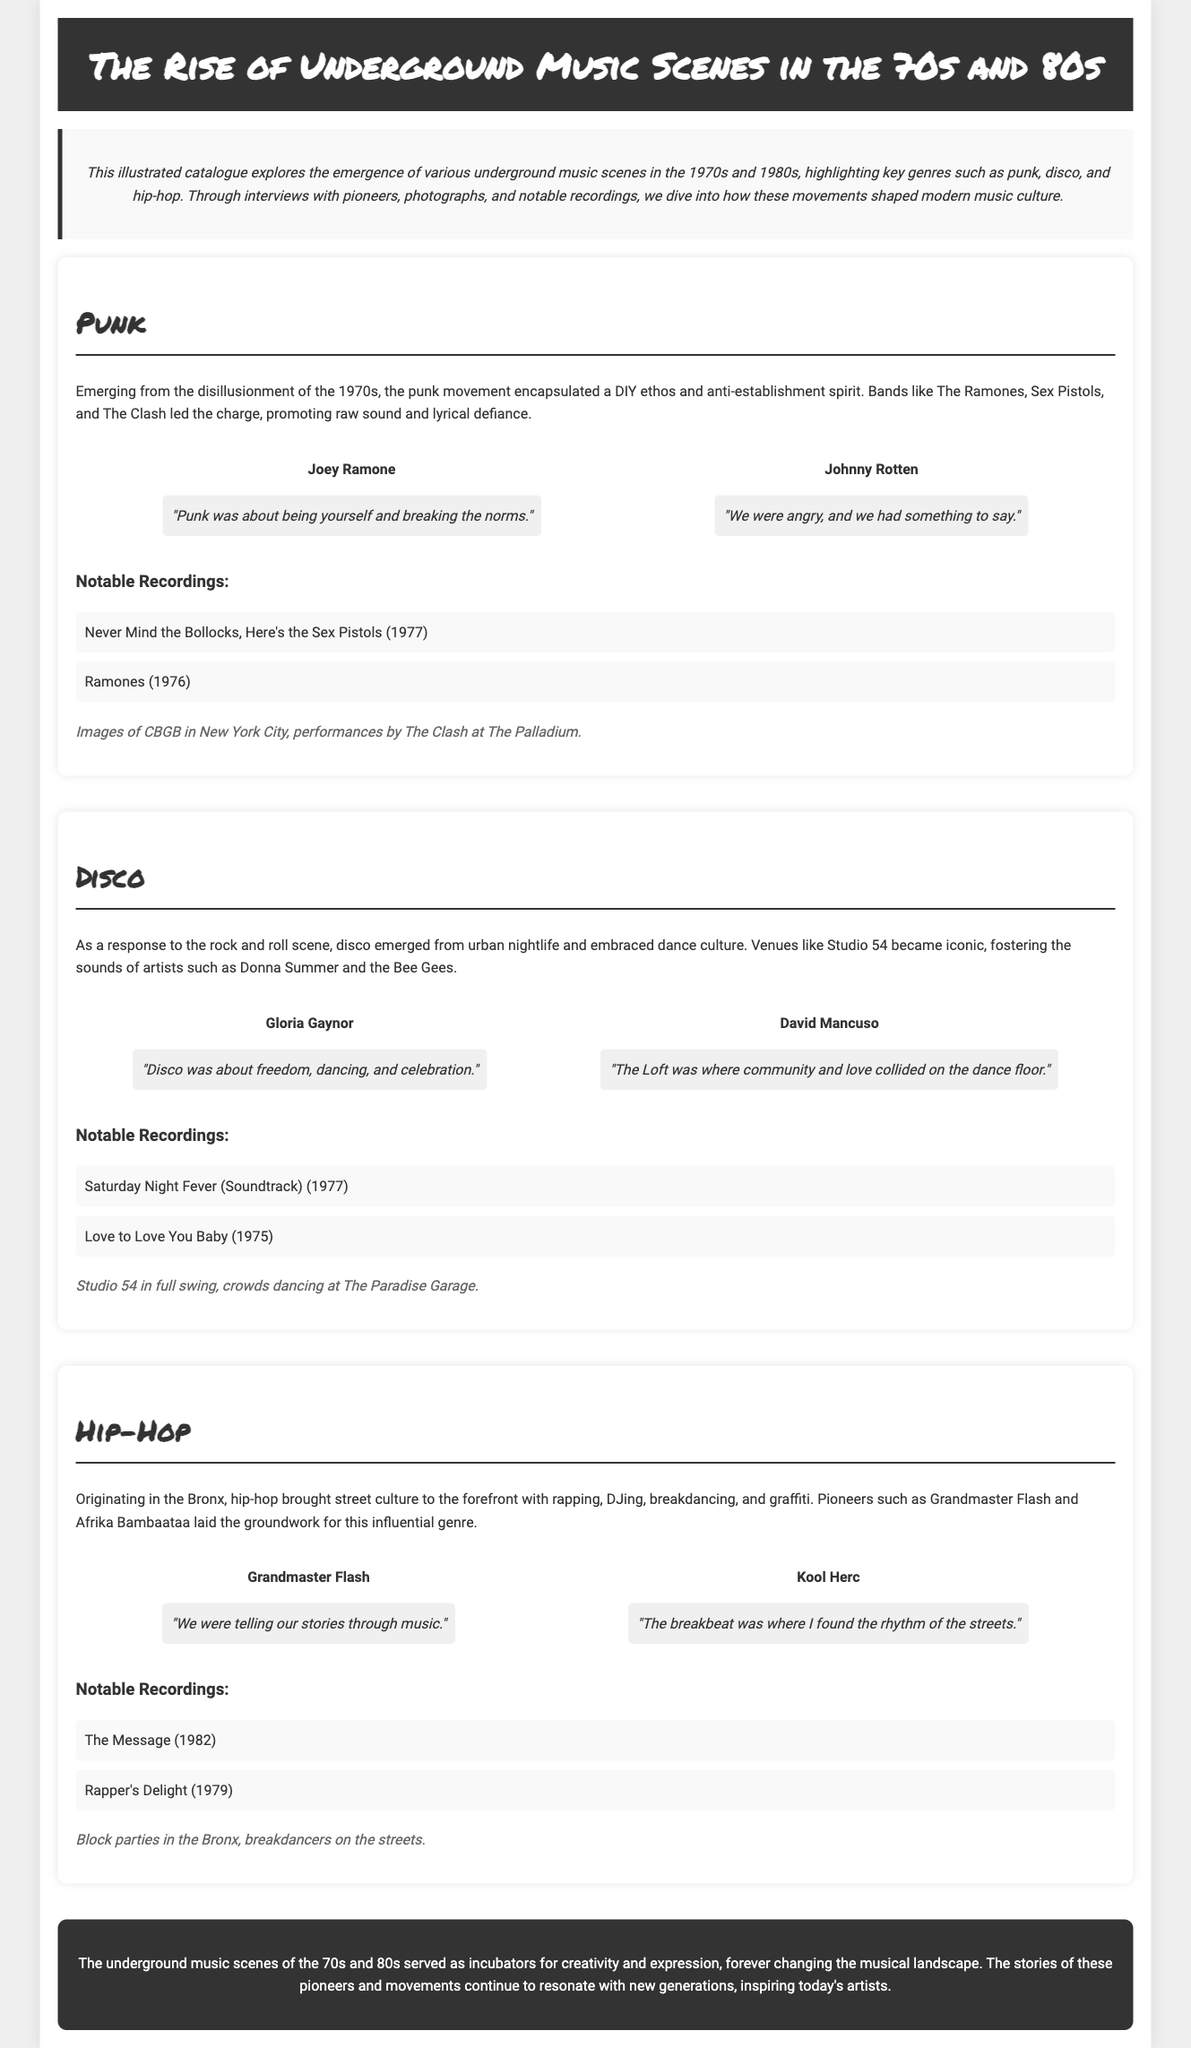what is the title of the catalogue? The title of the catalogue is prominently displayed in the header section, which reads "The Rise of Underground Music Scenes in the 70s and 80s."
Answer: The Rise of Underground Music Scenes in the 70s and 80s who are two pioneers of the punk genre? The document lists two pioneers of the punk genre, providing their names in the section dedicated to punk music.
Answer: Joey Ramone, Johnny Rotten which year was "Never Mind the Bollocks, Here's the Sex Pistols" released? The catalogue provides the release year of the notable recording in the punk genre section, which is stated as 1977.
Answer: 1977 what are the two notable recordings in the disco genre? The notable recordings for disco are listed in the disco genre section, identifying them clearly.
Answer: Saturday Night Fever, Love to Love You Baby what was the main focus of the hip-hop scene according to the document? The document outlines the main focus of the hip-hop scene, highlighting its cultural elements in the description provided.
Answer: Street culture who stated, "The Loft was where community and love collided on the dance floor"? This quote is attributed to a pioneer in the disco genre, as mentioned in the document.
Answer: David Mancuso how many notable recordings are listed for the hip-hop genre? The number of notable recordings is specified in the section for hip-hop music, which summarizes them.
Answer: 2 what key characteristic defined the punk movement? The document describes key characteristics of the punk movement, emphasizing one specific aspect prominently.
Answer: DIY ethos what venue became iconic for disco music? The catalogue refers to a specific venue that is highlighted as iconic for the disco genre in the description.
Answer: Studio 54 